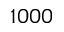Convert formula to latex. <formula><loc_0><loc_0><loc_500><loc_500>1 0 0 0</formula> 